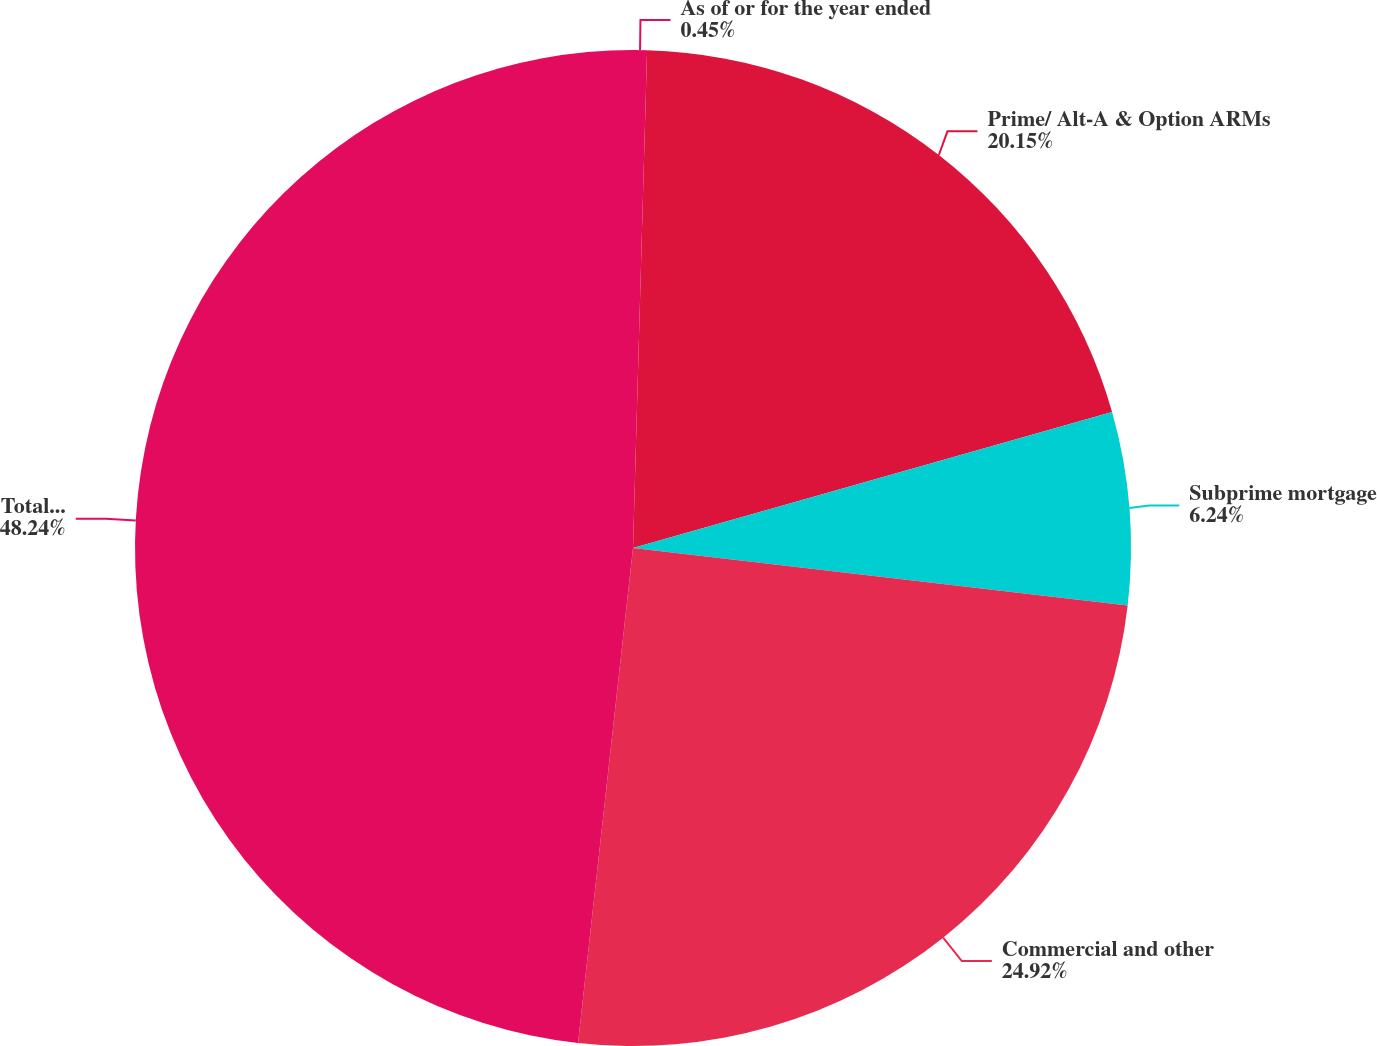<chart> <loc_0><loc_0><loc_500><loc_500><pie_chart><fcel>As of or for the year ended<fcel>Prime/ Alt-A & Option ARMs<fcel>Subprime mortgage<fcel>Commercial and other<fcel>Total loans securitized (b)<nl><fcel>0.45%<fcel>20.15%<fcel>6.24%<fcel>24.92%<fcel>48.24%<nl></chart> 